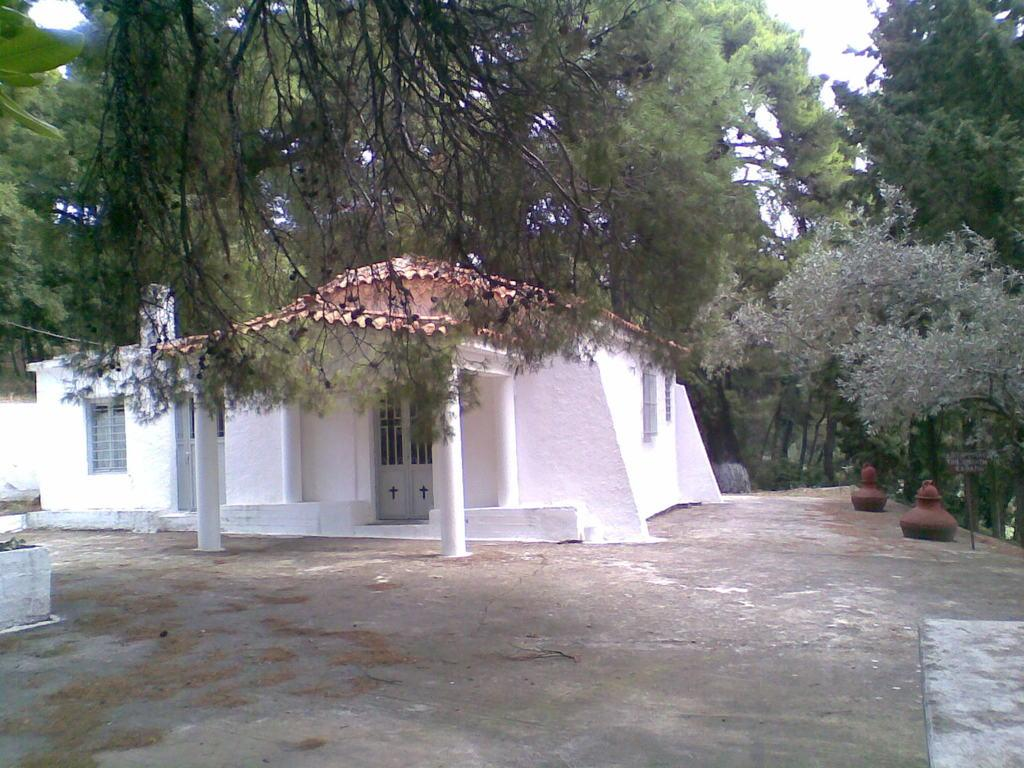What type of structure is in the image? There is a house in the image. What features can be seen on the house? The house has windows and a door. What is located near the house? There are trees around the house. What shape is the pet in the image? There is no pet present in the image. 